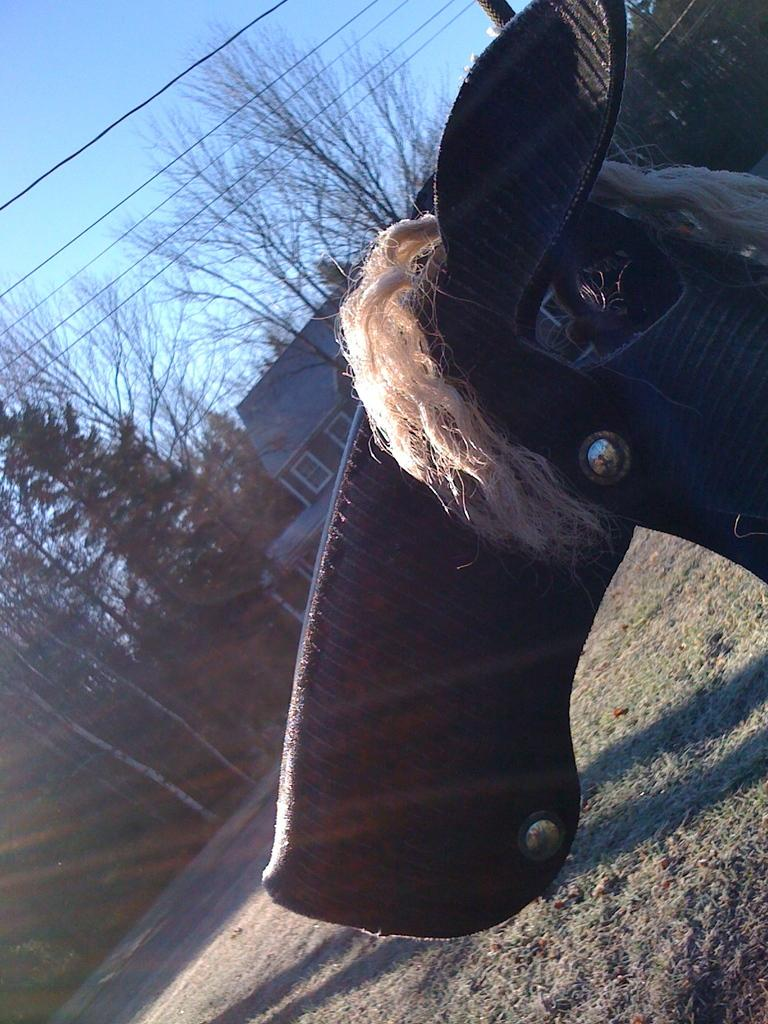What type of object is made of leather in the image? There is a leather object in the image. Where is the leather object located in the image? The leather object is towards the right side of the image. What is on the leather object? There are nuts and thread-like structures on the leather object. What can be seen in the background of the image? There is a building, trees, wires, and the sky visible in the background of the image. How many pies are being prepared by the expert in the image? There is no expert or pies present in the image. What type of stone is visible in the image? There is no stone visible in the image. 